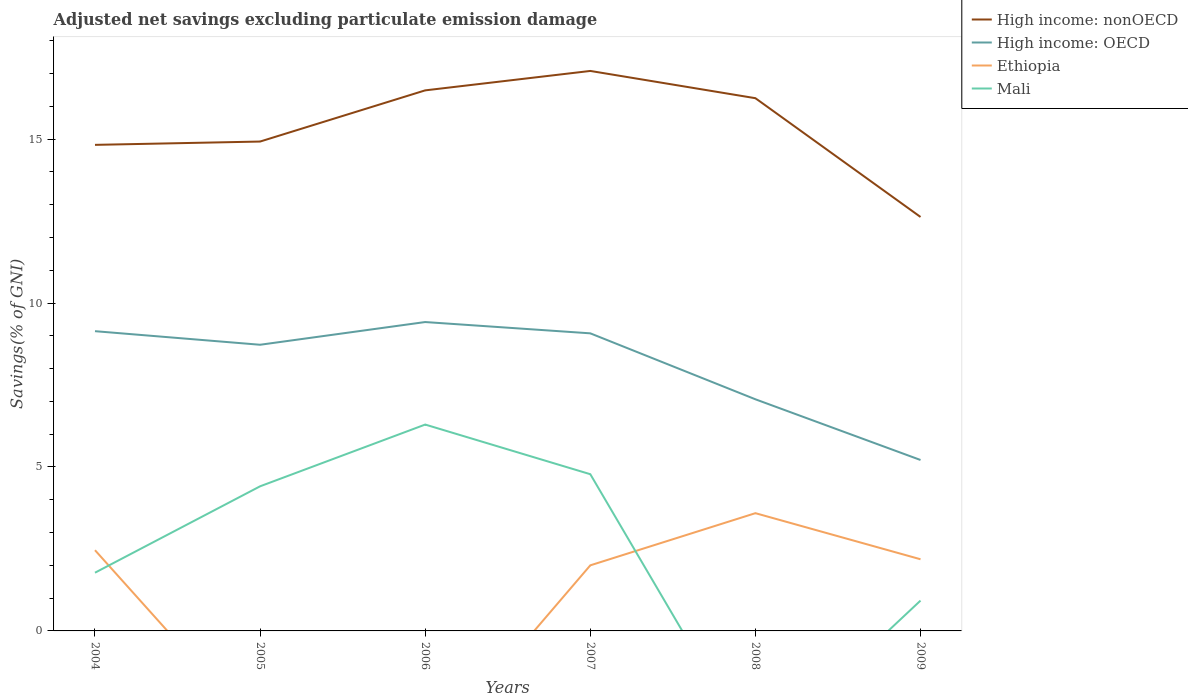How many different coloured lines are there?
Provide a succinct answer. 4. Does the line corresponding to High income: OECD intersect with the line corresponding to Ethiopia?
Give a very brief answer. No. Is the number of lines equal to the number of legend labels?
Your answer should be very brief. No. Across all years, what is the maximum adjusted net savings in High income: nonOECD?
Offer a terse response. 12.62. What is the total adjusted net savings in High income: nonOECD in the graph?
Your answer should be compact. 0.24. What is the difference between the highest and the second highest adjusted net savings in Mali?
Your answer should be very brief. 6.29. What is the difference between the highest and the lowest adjusted net savings in High income: nonOECD?
Give a very brief answer. 3. Is the adjusted net savings in Mali strictly greater than the adjusted net savings in High income: nonOECD over the years?
Offer a terse response. Yes. How many lines are there?
Ensure brevity in your answer.  4. What is the difference between two consecutive major ticks on the Y-axis?
Ensure brevity in your answer.  5. Are the values on the major ticks of Y-axis written in scientific E-notation?
Keep it short and to the point. No. Does the graph contain any zero values?
Give a very brief answer. Yes. How many legend labels are there?
Your answer should be very brief. 4. What is the title of the graph?
Your answer should be compact. Adjusted net savings excluding particulate emission damage. What is the label or title of the X-axis?
Offer a very short reply. Years. What is the label or title of the Y-axis?
Provide a short and direct response. Savings(% of GNI). What is the Savings(% of GNI) of High income: nonOECD in 2004?
Ensure brevity in your answer.  14.82. What is the Savings(% of GNI) in High income: OECD in 2004?
Keep it short and to the point. 9.14. What is the Savings(% of GNI) in Ethiopia in 2004?
Offer a very short reply. 2.46. What is the Savings(% of GNI) of Mali in 2004?
Your answer should be very brief. 1.78. What is the Savings(% of GNI) of High income: nonOECD in 2005?
Make the answer very short. 14.92. What is the Savings(% of GNI) of High income: OECD in 2005?
Your answer should be very brief. 8.73. What is the Savings(% of GNI) of Mali in 2005?
Keep it short and to the point. 4.41. What is the Savings(% of GNI) of High income: nonOECD in 2006?
Make the answer very short. 16.49. What is the Savings(% of GNI) in High income: OECD in 2006?
Provide a succinct answer. 9.42. What is the Savings(% of GNI) in Mali in 2006?
Offer a very short reply. 6.29. What is the Savings(% of GNI) in High income: nonOECD in 2007?
Ensure brevity in your answer.  17.08. What is the Savings(% of GNI) in High income: OECD in 2007?
Offer a terse response. 9.08. What is the Savings(% of GNI) of Ethiopia in 2007?
Make the answer very short. 2. What is the Savings(% of GNI) of Mali in 2007?
Ensure brevity in your answer.  4.78. What is the Savings(% of GNI) in High income: nonOECD in 2008?
Offer a very short reply. 16.25. What is the Savings(% of GNI) of High income: OECD in 2008?
Your response must be concise. 7.06. What is the Savings(% of GNI) of Ethiopia in 2008?
Ensure brevity in your answer.  3.59. What is the Savings(% of GNI) in High income: nonOECD in 2009?
Your response must be concise. 12.62. What is the Savings(% of GNI) of High income: OECD in 2009?
Your response must be concise. 5.21. What is the Savings(% of GNI) of Ethiopia in 2009?
Ensure brevity in your answer.  2.19. What is the Savings(% of GNI) in Mali in 2009?
Offer a very short reply. 0.93. Across all years, what is the maximum Savings(% of GNI) in High income: nonOECD?
Make the answer very short. 17.08. Across all years, what is the maximum Savings(% of GNI) in High income: OECD?
Offer a terse response. 9.42. Across all years, what is the maximum Savings(% of GNI) in Ethiopia?
Your answer should be very brief. 3.59. Across all years, what is the maximum Savings(% of GNI) in Mali?
Make the answer very short. 6.29. Across all years, what is the minimum Savings(% of GNI) of High income: nonOECD?
Ensure brevity in your answer.  12.62. Across all years, what is the minimum Savings(% of GNI) of High income: OECD?
Your answer should be compact. 5.21. Across all years, what is the minimum Savings(% of GNI) of Ethiopia?
Keep it short and to the point. 0. What is the total Savings(% of GNI) of High income: nonOECD in the graph?
Offer a terse response. 92.18. What is the total Savings(% of GNI) in High income: OECD in the graph?
Your answer should be compact. 48.64. What is the total Savings(% of GNI) of Ethiopia in the graph?
Keep it short and to the point. 10.24. What is the total Savings(% of GNI) in Mali in the graph?
Provide a short and direct response. 18.18. What is the difference between the Savings(% of GNI) in High income: nonOECD in 2004 and that in 2005?
Make the answer very short. -0.1. What is the difference between the Savings(% of GNI) in High income: OECD in 2004 and that in 2005?
Offer a terse response. 0.41. What is the difference between the Savings(% of GNI) in Mali in 2004 and that in 2005?
Provide a succinct answer. -2.63. What is the difference between the Savings(% of GNI) in High income: nonOECD in 2004 and that in 2006?
Offer a terse response. -1.66. What is the difference between the Savings(% of GNI) in High income: OECD in 2004 and that in 2006?
Offer a terse response. -0.28. What is the difference between the Savings(% of GNI) of Mali in 2004 and that in 2006?
Provide a succinct answer. -4.52. What is the difference between the Savings(% of GNI) of High income: nonOECD in 2004 and that in 2007?
Your answer should be compact. -2.25. What is the difference between the Savings(% of GNI) of High income: OECD in 2004 and that in 2007?
Your answer should be very brief. 0.07. What is the difference between the Savings(% of GNI) in Ethiopia in 2004 and that in 2007?
Offer a terse response. 0.46. What is the difference between the Savings(% of GNI) in Mali in 2004 and that in 2007?
Provide a short and direct response. -3. What is the difference between the Savings(% of GNI) in High income: nonOECD in 2004 and that in 2008?
Ensure brevity in your answer.  -1.42. What is the difference between the Savings(% of GNI) of High income: OECD in 2004 and that in 2008?
Your response must be concise. 2.08. What is the difference between the Savings(% of GNI) in Ethiopia in 2004 and that in 2008?
Provide a short and direct response. -1.13. What is the difference between the Savings(% of GNI) of High income: nonOECD in 2004 and that in 2009?
Make the answer very short. 2.2. What is the difference between the Savings(% of GNI) in High income: OECD in 2004 and that in 2009?
Your response must be concise. 3.93. What is the difference between the Savings(% of GNI) of Ethiopia in 2004 and that in 2009?
Your answer should be compact. 0.28. What is the difference between the Savings(% of GNI) in Mali in 2004 and that in 2009?
Make the answer very short. 0.85. What is the difference between the Savings(% of GNI) in High income: nonOECD in 2005 and that in 2006?
Make the answer very short. -1.56. What is the difference between the Savings(% of GNI) of High income: OECD in 2005 and that in 2006?
Your response must be concise. -0.69. What is the difference between the Savings(% of GNI) of Mali in 2005 and that in 2006?
Make the answer very short. -1.88. What is the difference between the Savings(% of GNI) in High income: nonOECD in 2005 and that in 2007?
Keep it short and to the point. -2.15. What is the difference between the Savings(% of GNI) in High income: OECD in 2005 and that in 2007?
Give a very brief answer. -0.35. What is the difference between the Savings(% of GNI) of Mali in 2005 and that in 2007?
Your answer should be very brief. -0.37. What is the difference between the Savings(% of GNI) in High income: nonOECD in 2005 and that in 2008?
Provide a succinct answer. -1.32. What is the difference between the Savings(% of GNI) of High income: OECD in 2005 and that in 2008?
Your response must be concise. 1.66. What is the difference between the Savings(% of GNI) of High income: nonOECD in 2005 and that in 2009?
Keep it short and to the point. 2.3. What is the difference between the Savings(% of GNI) of High income: OECD in 2005 and that in 2009?
Keep it short and to the point. 3.51. What is the difference between the Savings(% of GNI) of Mali in 2005 and that in 2009?
Your response must be concise. 3.49. What is the difference between the Savings(% of GNI) in High income: nonOECD in 2006 and that in 2007?
Offer a terse response. -0.59. What is the difference between the Savings(% of GNI) of High income: OECD in 2006 and that in 2007?
Provide a short and direct response. 0.34. What is the difference between the Savings(% of GNI) of Mali in 2006 and that in 2007?
Offer a very short reply. 1.51. What is the difference between the Savings(% of GNI) of High income: nonOECD in 2006 and that in 2008?
Ensure brevity in your answer.  0.24. What is the difference between the Savings(% of GNI) in High income: OECD in 2006 and that in 2008?
Give a very brief answer. 2.36. What is the difference between the Savings(% of GNI) in High income: nonOECD in 2006 and that in 2009?
Ensure brevity in your answer.  3.86. What is the difference between the Savings(% of GNI) in High income: OECD in 2006 and that in 2009?
Offer a terse response. 4.21. What is the difference between the Savings(% of GNI) of Mali in 2006 and that in 2009?
Your answer should be compact. 5.37. What is the difference between the Savings(% of GNI) of High income: nonOECD in 2007 and that in 2008?
Give a very brief answer. 0.83. What is the difference between the Savings(% of GNI) of High income: OECD in 2007 and that in 2008?
Your response must be concise. 2.01. What is the difference between the Savings(% of GNI) of Ethiopia in 2007 and that in 2008?
Ensure brevity in your answer.  -1.59. What is the difference between the Savings(% of GNI) in High income: nonOECD in 2007 and that in 2009?
Give a very brief answer. 4.45. What is the difference between the Savings(% of GNI) in High income: OECD in 2007 and that in 2009?
Provide a succinct answer. 3.86. What is the difference between the Savings(% of GNI) in Ethiopia in 2007 and that in 2009?
Your answer should be compact. -0.19. What is the difference between the Savings(% of GNI) of Mali in 2007 and that in 2009?
Your answer should be very brief. 3.85. What is the difference between the Savings(% of GNI) in High income: nonOECD in 2008 and that in 2009?
Your response must be concise. 3.62. What is the difference between the Savings(% of GNI) of High income: OECD in 2008 and that in 2009?
Your answer should be compact. 1.85. What is the difference between the Savings(% of GNI) in Ethiopia in 2008 and that in 2009?
Make the answer very short. 1.41. What is the difference between the Savings(% of GNI) in High income: nonOECD in 2004 and the Savings(% of GNI) in High income: OECD in 2005?
Offer a terse response. 6.1. What is the difference between the Savings(% of GNI) in High income: nonOECD in 2004 and the Savings(% of GNI) in Mali in 2005?
Your answer should be very brief. 10.41. What is the difference between the Savings(% of GNI) in High income: OECD in 2004 and the Savings(% of GNI) in Mali in 2005?
Offer a very short reply. 4.73. What is the difference between the Savings(% of GNI) of Ethiopia in 2004 and the Savings(% of GNI) of Mali in 2005?
Keep it short and to the point. -1.95. What is the difference between the Savings(% of GNI) in High income: nonOECD in 2004 and the Savings(% of GNI) in High income: OECD in 2006?
Your answer should be compact. 5.4. What is the difference between the Savings(% of GNI) in High income: nonOECD in 2004 and the Savings(% of GNI) in Mali in 2006?
Offer a very short reply. 8.53. What is the difference between the Savings(% of GNI) of High income: OECD in 2004 and the Savings(% of GNI) of Mali in 2006?
Make the answer very short. 2.85. What is the difference between the Savings(% of GNI) in Ethiopia in 2004 and the Savings(% of GNI) in Mali in 2006?
Your response must be concise. -3.83. What is the difference between the Savings(% of GNI) of High income: nonOECD in 2004 and the Savings(% of GNI) of High income: OECD in 2007?
Your response must be concise. 5.75. What is the difference between the Savings(% of GNI) in High income: nonOECD in 2004 and the Savings(% of GNI) in Ethiopia in 2007?
Make the answer very short. 12.82. What is the difference between the Savings(% of GNI) of High income: nonOECD in 2004 and the Savings(% of GNI) of Mali in 2007?
Provide a short and direct response. 10.04. What is the difference between the Savings(% of GNI) in High income: OECD in 2004 and the Savings(% of GNI) in Ethiopia in 2007?
Your answer should be compact. 7.14. What is the difference between the Savings(% of GNI) of High income: OECD in 2004 and the Savings(% of GNI) of Mali in 2007?
Offer a very short reply. 4.36. What is the difference between the Savings(% of GNI) of Ethiopia in 2004 and the Savings(% of GNI) of Mali in 2007?
Keep it short and to the point. -2.32. What is the difference between the Savings(% of GNI) in High income: nonOECD in 2004 and the Savings(% of GNI) in High income: OECD in 2008?
Your response must be concise. 7.76. What is the difference between the Savings(% of GNI) in High income: nonOECD in 2004 and the Savings(% of GNI) in Ethiopia in 2008?
Give a very brief answer. 11.23. What is the difference between the Savings(% of GNI) in High income: OECD in 2004 and the Savings(% of GNI) in Ethiopia in 2008?
Offer a very short reply. 5.55. What is the difference between the Savings(% of GNI) in High income: nonOECD in 2004 and the Savings(% of GNI) in High income: OECD in 2009?
Keep it short and to the point. 9.61. What is the difference between the Savings(% of GNI) of High income: nonOECD in 2004 and the Savings(% of GNI) of Ethiopia in 2009?
Keep it short and to the point. 12.64. What is the difference between the Savings(% of GNI) of High income: nonOECD in 2004 and the Savings(% of GNI) of Mali in 2009?
Provide a short and direct response. 13.9. What is the difference between the Savings(% of GNI) of High income: OECD in 2004 and the Savings(% of GNI) of Ethiopia in 2009?
Provide a succinct answer. 6.96. What is the difference between the Savings(% of GNI) in High income: OECD in 2004 and the Savings(% of GNI) in Mali in 2009?
Keep it short and to the point. 8.22. What is the difference between the Savings(% of GNI) in Ethiopia in 2004 and the Savings(% of GNI) in Mali in 2009?
Your answer should be very brief. 1.54. What is the difference between the Savings(% of GNI) of High income: nonOECD in 2005 and the Savings(% of GNI) of High income: OECD in 2006?
Keep it short and to the point. 5.5. What is the difference between the Savings(% of GNI) of High income: nonOECD in 2005 and the Savings(% of GNI) of Mali in 2006?
Provide a short and direct response. 8.63. What is the difference between the Savings(% of GNI) in High income: OECD in 2005 and the Savings(% of GNI) in Mali in 2006?
Keep it short and to the point. 2.43. What is the difference between the Savings(% of GNI) of High income: nonOECD in 2005 and the Savings(% of GNI) of High income: OECD in 2007?
Your answer should be very brief. 5.85. What is the difference between the Savings(% of GNI) of High income: nonOECD in 2005 and the Savings(% of GNI) of Ethiopia in 2007?
Keep it short and to the point. 12.92. What is the difference between the Savings(% of GNI) in High income: nonOECD in 2005 and the Savings(% of GNI) in Mali in 2007?
Your response must be concise. 10.15. What is the difference between the Savings(% of GNI) of High income: OECD in 2005 and the Savings(% of GNI) of Ethiopia in 2007?
Provide a succinct answer. 6.73. What is the difference between the Savings(% of GNI) in High income: OECD in 2005 and the Savings(% of GNI) in Mali in 2007?
Keep it short and to the point. 3.95. What is the difference between the Savings(% of GNI) in High income: nonOECD in 2005 and the Savings(% of GNI) in High income: OECD in 2008?
Provide a short and direct response. 7.86. What is the difference between the Savings(% of GNI) in High income: nonOECD in 2005 and the Savings(% of GNI) in Ethiopia in 2008?
Offer a very short reply. 11.33. What is the difference between the Savings(% of GNI) in High income: OECD in 2005 and the Savings(% of GNI) in Ethiopia in 2008?
Keep it short and to the point. 5.14. What is the difference between the Savings(% of GNI) in High income: nonOECD in 2005 and the Savings(% of GNI) in High income: OECD in 2009?
Provide a short and direct response. 9.71. What is the difference between the Savings(% of GNI) of High income: nonOECD in 2005 and the Savings(% of GNI) of Ethiopia in 2009?
Give a very brief answer. 12.74. What is the difference between the Savings(% of GNI) of High income: nonOECD in 2005 and the Savings(% of GNI) of Mali in 2009?
Provide a succinct answer. 14. What is the difference between the Savings(% of GNI) of High income: OECD in 2005 and the Savings(% of GNI) of Ethiopia in 2009?
Keep it short and to the point. 6.54. What is the difference between the Savings(% of GNI) in High income: OECD in 2005 and the Savings(% of GNI) in Mali in 2009?
Offer a very short reply. 7.8. What is the difference between the Savings(% of GNI) in High income: nonOECD in 2006 and the Savings(% of GNI) in High income: OECD in 2007?
Provide a short and direct response. 7.41. What is the difference between the Savings(% of GNI) in High income: nonOECD in 2006 and the Savings(% of GNI) in Ethiopia in 2007?
Keep it short and to the point. 14.49. What is the difference between the Savings(% of GNI) in High income: nonOECD in 2006 and the Savings(% of GNI) in Mali in 2007?
Ensure brevity in your answer.  11.71. What is the difference between the Savings(% of GNI) of High income: OECD in 2006 and the Savings(% of GNI) of Ethiopia in 2007?
Provide a succinct answer. 7.42. What is the difference between the Savings(% of GNI) of High income: OECD in 2006 and the Savings(% of GNI) of Mali in 2007?
Offer a terse response. 4.64. What is the difference between the Savings(% of GNI) of High income: nonOECD in 2006 and the Savings(% of GNI) of High income: OECD in 2008?
Your answer should be compact. 9.42. What is the difference between the Savings(% of GNI) in High income: nonOECD in 2006 and the Savings(% of GNI) in Ethiopia in 2008?
Your answer should be very brief. 12.89. What is the difference between the Savings(% of GNI) in High income: OECD in 2006 and the Savings(% of GNI) in Ethiopia in 2008?
Make the answer very short. 5.83. What is the difference between the Savings(% of GNI) of High income: nonOECD in 2006 and the Savings(% of GNI) of High income: OECD in 2009?
Offer a very short reply. 11.27. What is the difference between the Savings(% of GNI) in High income: nonOECD in 2006 and the Savings(% of GNI) in Ethiopia in 2009?
Provide a short and direct response. 14.3. What is the difference between the Savings(% of GNI) of High income: nonOECD in 2006 and the Savings(% of GNI) of Mali in 2009?
Keep it short and to the point. 15.56. What is the difference between the Savings(% of GNI) of High income: OECD in 2006 and the Savings(% of GNI) of Ethiopia in 2009?
Provide a short and direct response. 7.23. What is the difference between the Savings(% of GNI) of High income: OECD in 2006 and the Savings(% of GNI) of Mali in 2009?
Give a very brief answer. 8.49. What is the difference between the Savings(% of GNI) in High income: nonOECD in 2007 and the Savings(% of GNI) in High income: OECD in 2008?
Provide a short and direct response. 10.01. What is the difference between the Savings(% of GNI) in High income: nonOECD in 2007 and the Savings(% of GNI) in Ethiopia in 2008?
Give a very brief answer. 13.49. What is the difference between the Savings(% of GNI) of High income: OECD in 2007 and the Savings(% of GNI) of Ethiopia in 2008?
Your answer should be compact. 5.48. What is the difference between the Savings(% of GNI) of High income: nonOECD in 2007 and the Savings(% of GNI) of High income: OECD in 2009?
Your answer should be compact. 11.87. What is the difference between the Savings(% of GNI) in High income: nonOECD in 2007 and the Savings(% of GNI) in Ethiopia in 2009?
Make the answer very short. 14.89. What is the difference between the Savings(% of GNI) in High income: nonOECD in 2007 and the Savings(% of GNI) in Mali in 2009?
Keep it short and to the point. 16.15. What is the difference between the Savings(% of GNI) in High income: OECD in 2007 and the Savings(% of GNI) in Ethiopia in 2009?
Keep it short and to the point. 6.89. What is the difference between the Savings(% of GNI) in High income: OECD in 2007 and the Savings(% of GNI) in Mali in 2009?
Provide a short and direct response. 8.15. What is the difference between the Savings(% of GNI) in Ethiopia in 2007 and the Savings(% of GNI) in Mali in 2009?
Offer a terse response. 1.07. What is the difference between the Savings(% of GNI) of High income: nonOECD in 2008 and the Savings(% of GNI) of High income: OECD in 2009?
Offer a terse response. 11.03. What is the difference between the Savings(% of GNI) in High income: nonOECD in 2008 and the Savings(% of GNI) in Ethiopia in 2009?
Your answer should be very brief. 14.06. What is the difference between the Savings(% of GNI) in High income: nonOECD in 2008 and the Savings(% of GNI) in Mali in 2009?
Your answer should be compact. 15.32. What is the difference between the Savings(% of GNI) of High income: OECD in 2008 and the Savings(% of GNI) of Ethiopia in 2009?
Your answer should be very brief. 4.88. What is the difference between the Savings(% of GNI) in High income: OECD in 2008 and the Savings(% of GNI) in Mali in 2009?
Give a very brief answer. 6.14. What is the difference between the Savings(% of GNI) in Ethiopia in 2008 and the Savings(% of GNI) in Mali in 2009?
Ensure brevity in your answer.  2.67. What is the average Savings(% of GNI) of High income: nonOECD per year?
Provide a short and direct response. 15.36. What is the average Savings(% of GNI) of High income: OECD per year?
Ensure brevity in your answer.  8.11. What is the average Savings(% of GNI) in Ethiopia per year?
Your answer should be very brief. 1.71. What is the average Savings(% of GNI) in Mali per year?
Your response must be concise. 3.03. In the year 2004, what is the difference between the Savings(% of GNI) of High income: nonOECD and Savings(% of GNI) of High income: OECD?
Offer a terse response. 5.68. In the year 2004, what is the difference between the Savings(% of GNI) in High income: nonOECD and Savings(% of GNI) in Ethiopia?
Keep it short and to the point. 12.36. In the year 2004, what is the difference between the Savings(% of GNI) of High income: nonOECD and Savings(% of GNI) of Mali?
Your response must be concise. 13.05. In the year 2004, what is the difference between the Savings(% of GNI) in High income: OECD and Savings(% of GNI) in Ethiopia?
Offer a very short reply. 6.68. In the year 2004, what is the difference between the Savings(% of GNI) in High income: OECD and Savings(% of GNI) in Mali?
Ensure brevity in your answer.  7.37. In the year 2004, what is the difference between the Savings(% of GNI) of Ethiopia and Savings(% of GNI) of Mali?
Your answer should be very brief. 0.69. In the year 2005, what is the difference between the Savings(% of GNI) in High income: nonOECD and Savings(% of GNI) in High income: OECD?
Provide a succinct answer. 6.2. In the year 2005, what is the difference between the Savings(% of GNI) in High income: nonOECD and Savings(% of GNI) in Mali?
Offer a very short reply. 10.51. In the year 2005, what is the difference between the Savings(% of GNI) of High income: OECD and Savings(% of GNI) of Mali?
Offer a very short reply. 4.32. In the year 2006, what is the difference between the Savings(% of GNI) in High income: nonOECD and Savings(% of GNI) in High income: OECD?
Ensure brevity in your answer.  7.07. In the year 2006, what is the difference between the Savings(% of GNI) of High income: nonOECD and Savings(% of GNI) of Mali?
Your answer should be compact. 10.19. In the year 2006, what is the difference between the Savings(% of GNI) of High income: OECD and Savings(% of GNI) of Mali?
Provide a succinct answer. 3.13. In the year 2007, what is the difference between the Savings(% of GNI) of High income: nonOECD and Savings(% of GNI) of High income: OECD?
Make the answer very short. 8. In the year 2007, what is the difference between the Savings(% of GNI) in High income: nonOECD and Savings(% of GNI) in Ethiopia?
Offer a terse response. 15.08. In the year 2007, what is the difference between the Savings(% of GNI) of High income: nonOECD and Savings(% of GNI) of Mali?
Offer a terse response. 12.3. In the year 2007, what is the difference between the Savings(% of GNI) in High income: OECD and Savings(% of GNI) in Ethiopia?
Keep it short and to the point. 7.08. In the year 2007, what is the difference between the Savings(% of GNI) in High income: OECD and Savings(% of GNI) in Mali?
Provide a short and direct response. 4.3. In the year 2007, what is the difference between the Savings(% of GNI) in Ethiopia and Savings(% of GNI) in Mali?
Your response must be concise. -2.78. In the year 2008, what is the difference between the Savings(% of GNI) of High income: nonOECD and Savings(% of GNI) of High income: OECD?
Make the answer very short. 9.18. In the year 2008, what is the difference between the Savings(% of GNI) of High income: nonOECD and Savings(% of GNI) of Ethiopia?
Make the answer very short. 12.66. In the year 2008, what is the difference between the Savings(% of GNI) in High income: OECD and Savings(% of GNI) in Ethiopia?
Give a very brief answer. 3.47. In the year 2009, what is the difference between the Savings(% of GNI) in High income: nonOECD and Savings(% of GNI) in High income: OECD?
Offer a very short reply. 7.41. In the year 2009, what is the difference between the Savings(% of GNI) of High income: nonOECD and Savings(% of GNI) of Ethiopia?
Offer a very short reply. 10.44. In the year 2009, what is the difference between the Savings(% of GNI) in High income: nonOECD and Savings(% of GNI) in Mali?
Your response must be concise. 11.7. In the year 2009, what is the difference between the Savings(% of GNI) of High income: OECD and Savings(% of GNI) of Ethiopia?
Your response must be concise. 3.03. In the year 2009, what is the difference between the Savings(% of GNI) in High income: OECD and Savings(% of GNI) in Mali?
Offer a very short reply. 4.29. In the year 2009, what is the difference between the Savings(% of GNI) in Ethiopia and Savings(% of GNI) in Mali?
Provide a succinct answer. 1.26. What is the ratio of the Savings(% of GNI) in High income: nonOECD in 2004 to that in 2005?
Your response must be concise. 0.99. What is the ratio of the Savings(% of GNI) of High income: OECD in 2004 to that in 2005?
Offer a very short reply. 1.05. What is the ratio of the Savings(% of GNI) in Mali in 2004 to that in 2005?
Your answer should be compact. 0.4. What is the ratio of the Savings(% of GNI) of High income: nonOECD in 2004 to that in 2006?
Your response must be concise. 0.9. What is the ratio of the Savings(% of GNI) of High income: OECD in 2004 to that in 2006?
Offer a very short reply. 0.97. What is the ratio of the Savings(% of GNI) in Mali in 2004 to that in 2006?
Offer a very short reply. 0.28. What is the ratio of the Savings(% of GNI) in High income: nonOECD in 2004 to that in 2007?
Offer a very short reply. 0.87. What is the ratio of the Savings(% of GNI) of High income: OECD in 2004 to that in 2007?
Your answer should be very brief. 1.01. What is the ratio of the Savings(% of GNI) of Ethiopia in 2004 to that in 2007?
Give a very brief answer. 1.23. What is the ratio of the Savings(% of GNI) in Mali in 2004 to that in 2007?
Your answer should be compact. 0.37. What is the ratio of the Savings(% of GNI) in High income: nonOECD in 2004 to that in 2008?
Offer a terse response. 0.91. What is the ratio of the Savings(% of GNI) in High income: OECD in 2004 to that in 2008?
Your answer should be compact. 1.29. What is the ratio of the Savings(% of GNI) of Ethiopia in 2004 to that in 2008?
Provide a succinct answer. 0.69. What is the ratio of the Savings(% of GNI) of High income: nonOECD in 2004 to that in 2009?
Your answer should be compact. 1.17. What is the ratio of the Savings(% of GNI) of High income: OECD in 2004 to that in 2009?
Ensure brevity in your answer.  1.75. What is the ratio of the Savings(% of GNI) in Ethiopia in 2004 to that in 2009?
Your answer should be very brief. 1.13. What is the ratio of the Savings(% of GNI) in Mali in 2004 to that in 2009?
Make the answer very short. 1.92. What is the ratio of the Savings(% of GNI) of High income: nonOECD in 2005 to that in 2006?
Ensure brevity in your answer.  0.91. What is the ratio of the Savings(% of GNI) in High income: OECD in 2005 to that in 2006?
Give a very brief answer. 0.93. What is the ratio of the Savings(% of GNI) of Mali in 2005 to that in 2006?
Your response must be concise. 0.7. What is the ratio of the Savings(% of GNI) of High income: nonOECD in 2005 to that in 2007?
Make the answer very short. 0.87. What is the ratio of the Savings(% of GNI) of High income: OECD in 2005 to that in 2007?
Ensure brevity in your answer.  0.96. What is the ratio of the Savings(% of GNI) in Mali in 2005 to that in 2007?
Provide a short and direct response. 0.92. What is the ratio of the Savings(% of GNI) of High income: nonOECD in 2005 to that in 2008?
Your response must be concise. 0.92. What is the ratio of the Savings(% of GNI) of High income: OECD in 2005 to that in 2008?
Provide a short and direct response. 1.24. What is the ratio of the Savings(% of GNI) in High income: nonOECD in 2005 to that in 2009?
Make the answer very short. 1.18. What is the ratio of the Savings(% of GNI) in High income: OECD in 2005 to that in 2009?
Offer a very short reply. 1.67. What is the ratio of the Savings(% of GNI) in Mali in 2005 to that in 2009?
Your answer should be compact. 4.77. What is the ratio of the Savings(% of GNI) in High income: nonOECD in 2006 to that in 2007?
Make the answer very short. 0.97. What is the ratio of the Savings(% of GNI) of High income: OECD in 2006 to that in 2007?
Offer a very short reply. 1.04. What is the ratio of the Savings(% of GNI) of Mali in 2006 to that in 2007?
Make the answer very short. 1.32. What is the ratio of the Savings(% of GNI) of High income: nonOECD in 2006 to that in 2008?
Give a very brief answer. 1.01. What is the ratio of the Savings(% of GNI) in High income: OECD in 2006 to that in 2008?
Provide a succinct answer. 1.33. What is the ratio of the Savings(% of GNI) of High income: nonOECD in 2006 to that in 2009?
Provide a short and direct response. 1.31. What is the ratio of the Savings(% of GNI) of High income: OECD in 2006 to that in 2009?
Your answer should be very brief. 1.81. What is the ratio of the Savings(% of GNI) of Mali in 2006 to that in 2009?
Your answer should be very brief. 6.8. What is the ratio of the Savings(% of GNI) in High income: nonOECD in 2007 to that in 2008?
Ensure brevity in your answer.  1.05. What is the ratio of the Savings(% of GNI) of High income: OECD in 2007 to that in 2008?
Provide a succinct answer. 1.28. What is the ratio of the Savings(% of GNI) in Ethiopia in 2007 to that in 2008?
Keep it short and to the point. 0.56. What is the ratio of the Savings(% of GNI) of High income: nonOECD in 2007 to that in 2009?
Provide a succinct answer. 1.35. What is the ratio of the Savings(% of GNI) of High income: OECD in 2007 to that in 2009?
Make the answer very short. 1.74. What is the ratio of the Savings(% of GNI) in Ethiopia in 2007 to that in 2009?
Offer a terse response. 0.92. What is the ratio of the Savings(% of GNI) of Mali in 2007 to that in 2009?
Your answer should be compact. 5.17. What is the ratio of the Savings(% of GNI) of High income: nonOECD in 2008 to that in 2009?
Ensure brevity in your answer.  1.29. What is the ratio of the Savings(% of GNI) of High income: OECD in 2008 to that in 2009?
Your answer should be compact. 1.36. What is the ratio of the Savings(% of GNI) of Ethiopia in 2008 to that in 2009?
Your response must be concise. 1.64. What is the difference between the highest and the second highest Savings(% of GNI) of High income: nonOECD?
Your response must be concise. 0.59. What is the difference between the highest and the second highest Savings(% of GNI) in High income: OECD?
Offer a very short reply. 0.28. What is the difference between the highest and the second highest Savings(% of GNI) of Ethiopia?
Provide a succinct answer. 1.13. What is the difference between the highest and the second highest Savings(% of GNI) in Mali?
Your answer should be very brief. 1.51. What is the difference between the highest and the lowest Savings(% of GNI) in High income: nonOECD?
Your answer should be compact. 4.45. What is the difference between the highest and the lowest Savings(% of GNI) of High income: OECD?
Offer a very short reply. 4.21. What is the difference between the highest and the lowest Savings(% of GNI) of Ethiopia?
Your answer should be compact. 3.59. What is the difference between the highest and the lowest Savings(% of GNI) in Mali?
Provide a short and direct response. 6.29. 